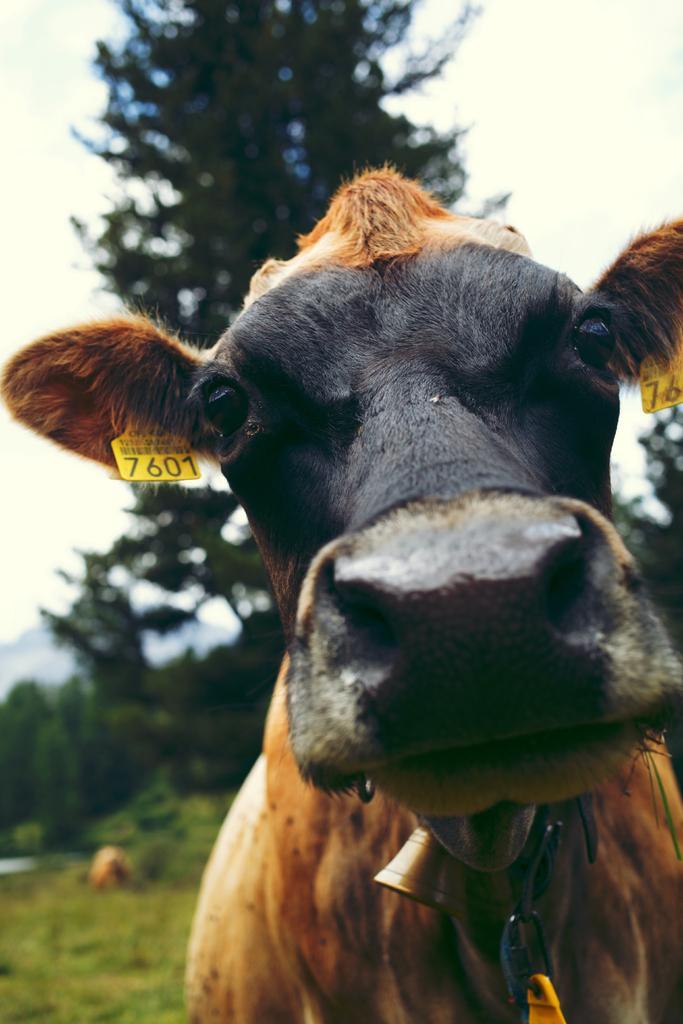Describe this image in one or two sentences. In this picture there is a cow. in the background I can see the trees, plants, mountains and grass. At the top right I can see the sky. 